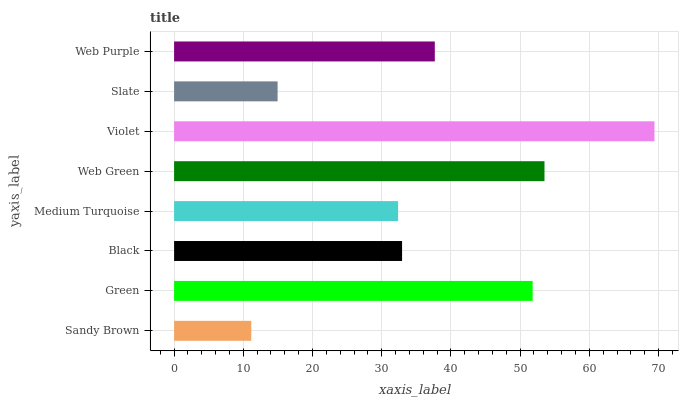Is Sandy Brown the minimum?
Answer yes or no. Yes. Is Violet the maximum?
Answer yes or no. Yes. Is Green the minimum?
Answer yes or no. No. Is Green the maximum?
Answer yes or no. No. Is Green greater than Sandy Brown?
Answer yes or no. Yes. Is Sandy Brown less than Green?
Answer yes or no. Yes. Is Sandy Brown greater than Green?
Answer yes or no. No. Is Green less than Sandy Brown?
Answer yes or no. No. Is Web Purple the high median?
Answer yes or no. Yes. Is Black the low median?
Answer yes or no. Yes. Is Green the high median?
Answer yes or no. No. Is Sandy Brown the low median?
Answer yes or no. No. 